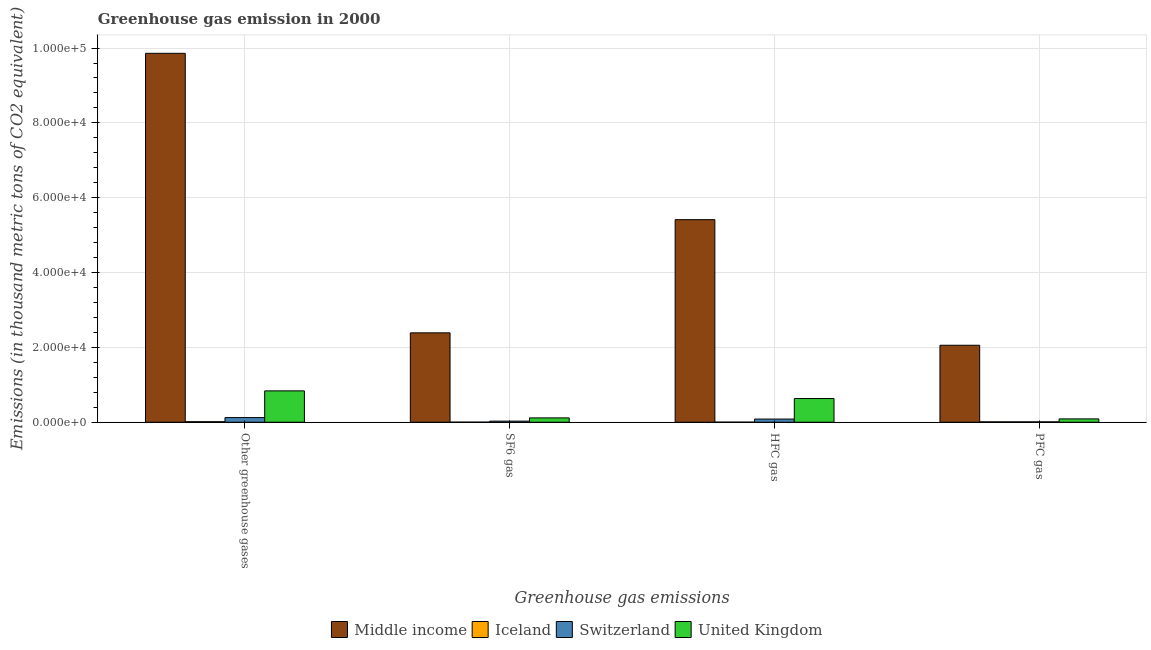How many different coloured bars are there?
Your answer should be very brief. 4. How many bars are there on the 4th tick from the left?
Your answer should be very brief. 4. What is the label of the 3rd group of bars from the left?
Provide a short and direct response. HFC gas. What is the emission of hfc gas in Middle income?
Provide a short and direct response. 5.41e+04. Across all countries, what is the maximum emission of pfc gas?
Your answer should be compact. 2.06e+04. Across all countries, what is the minimum emission of pfc gas?
Offer a very short reply. 97.9. In which country was the emission of hfc gas maximum?
Make the answer very short. Middle income. In which country was the emission of greenhouse gases minimum?
Provide a short and direct response. Iceland. What is the total emission of pfc gas in the graph?
Provide a succinct answer. 2.17e+04. What is the difference between the emission of pfc gas in Middle income and that in Iceland?
Your response must be concise. 2.05e+04. What is the difference between the emission of greenhouse gases in Middle income and the emission of sf6 gas in Switzerland?
Offer a very short reply. 9.83e+04. What is the average emission of sf6 gas per country?
Offer a very short reply. 6337.95. What is the difference between the emission of hfc gas and emission of greenhouse gases in Iceland?
Your answer should be compact. -122.5. What is the ratio of the emission of pfc gas in Middle income to that in Switzerland?
Give a very brief answer. 210.12. Is the difference between the emission of greenhouse gases in United Kingdom and Middle income greater than the difference between the emission of pfc gas in United Kingdom and Middle income?
Make the answer very short. No. What is the difference between the highest and the second highest emission of hfc gas?
Give a very brief answer. 4.78e+04. What is the difference between the highest and the lowest emission of sf6 gas?
Keep it short and to the point. 2.39e+04. Is it the case that in every country, the sum of the emission of pfc gas and emission of hfc gas is greater than the sum of emission of sf6 gas and emission of greenhouse gases?
Make the answer very short. No. What does the 3rd bar from the left in Other greenhouse gases represents?
Your response must be concise. Switzerland. What does the 1st bar from the right in HFC gas represents?
Make the answer very short. United Kingdom. Are all the bars in the graph horizontal?
Keep it short and to the point. No. How many countries are there in the graph?
Provide a short and direct response. 4. What is the difference between two consecutive major ticks on the Y-axis?
Keep it short and to the point. 2.00e+04. Does the graph contain any zero values?
Your response must be concise. No. Does the graph contain grids?
Provide a short and direct response. Yes. What is the title of the graph?
Offer a terse response. Greenhouse gas emission in 2000. Does "Korea (Democratic)" appear as one of the legend labels in the graph?
Your response must be concise. No. What is the label or title of the X-axis?
Give a very brief answer. Greenhouse gas emissions. What is the label or title of the Y-axis?
Your response must be concise. Emissions (in thousand metric tons of CO2 equivalent). What is the Emissions (in thousand metric tons of CO2 equivalent) of Middle income in Other greenhouse gases?
Your answer should be compact. 9.86e+04. What is the Emissions (in thousand metric tons of CO2 equivalent) of Iceland in Other greenhouse gases?
Give a very brief answer. 144.8. What is the Emissions (in thousand metric tons of CO2 equivalent) in Switzerland in Other greenhouse gases?
Provide a succinct answer. 1239.2. What is the Emissions (in thousand metric tons of CO2 equivalent) of United Kingdom in Other greenhouse gases?
Keep it short and to the point. 8376.7. What is the Emissions (in thousand metric tons of CO2 equivalent) in Middle income in SF6 gas?
Ensure brevity in your answer.  2.39e+04. What is the Emissions (in thousand metric tons of CO2 equivalent) of Iceland in SF6 gas?
Offer a terse response. 17.9. What is the Emissions (in thousand metric tons of CO2 equivalent) of Switzerland in SF6 gas?
Your answer should be very brief. 293.1. What is the Emissions (in thousand metric tons of CO2 equivalent) in United Kingdom in SF6 gas?
Your answer should be compact. 1154.1. What is the Emissions (in thousand metric tons of CO2 equivalent) of Middle income in HFC gas?
Offer a terse response. 5.41e+04. What is the Emissions (in thousand metric tons of CO2 equivalent) of Iceland in HFC gas?
Your answer should be compact. 22.3. What is the Emissions (in thousand metric tons of CO2 equivalent) in Switzerland in HFC gas?
Offer a terse response. 848.2. What is the Emissions (in thousand metric tons of CO2 equivalent) of United Kingdom in HFC gas?
Ensure brevity in your answer.  6332.5. What is the Emissions (in thousand metric tons of CO2 equivalent) in Middle income in PFC gas?
Provide a short and direct response. 2.06e+04. What is the Emissions (in thousand metric tons of CO2 equivalent) of Iceland in PFC gas?
Make the answer very short. 104.6. What is the Emissions (in thousand metric tons of CO2 equivalent) in Switzerland in PFC gas?
Your response must be concise. 97.9. What is the Emissions (in thousand metric tons of CO2 equivalent) in United Kingdom in PFC gas?
Your answer should be very brief. 890.1. Across all Greenhouse gas emissions, what is the maximum Emissions (in thousand metric tons of CO2 equivalent) of Middle income?
Ensure brevity in your answer.  9.86e+04. Across all Greenhouse gas emissions, what is the maximum Emissions (in thousand metric tons of CO2 equivalent) of Iceland?
Your answer should be compact. 144.8. Across all Greenhouse gas emissions, what is the maximum Emissions (in thousand metric tons of CO2 equivalent) of Switzerland?
Your answer should be compact. 1239.2. Across all Greenhouse gas emissions, what is the maximum Emissions (in thousand metric tons of CO2 equivalent) of United Kingdom?
Give a very brief answer. 8376.7. Across all Greenhouse gas emissions, what is the minimum Emissions (in thousand metric tons of CO2 equivalent) in Middle income?
Offer a terse response. 2.06e+04. Across all Greenhouse gas emissions, what is the minimum Emissions (in thousand metric tons of CO2 equivalent) of Switzerland?
Give a very brief answer. 97.9. Across all Greenhouse gas emissions, what is the minimum Emissions (in thousand metric tons of CO2 equivalent) in United Kingdom?
Give a very brief answer. 890.1. What is the total Emissions (in thousand metric tons of CO2 equivalent) of Middle income in the graph?
Your answer should be very brief. 1.97e+05. What is the total Emissions (in thousand metric tons of CO2 equivalent) in Iceland in the graph?
Your response must be concise. 289.6. What is the total Emissions (in thousand metric tons of CO2 equivalent) of Switzerland in the graph?
Make the answer very short. 2478.4. What is the total Emissions (in thousand metric tons of CO2 equivalent) of United Kingdom in the graph?
Keep it short and to the point. 1.68e+04. What is the difference between the Emissions (in thousand metric tons of CO2 equivalent) of Middle income in Other greenhouse gases and that in SF6 gas?
Keep it short and to the point. 7.47e+04. What is the difference between the Emissions (in thousand metric tons of CO2 equivalent) in Iceland in Other greenhouse gases and that in SF6 gas?
Offer a very short reply. 126.9. What is the difference between the Emissions (in thousand metric tons of CO2 equivalent) of Switzerland in Other greenhouse gases and that in SF6 gas?
Ensure brevity in your answer.  946.1. What is the difference between the Emissions (in thousand metric tons of CO2 equivalent) in United Kingdom in Other greenhouse gases and that in SF6 gas?
Your answer should be very brief. 7222.6. What is the difference between the Emissions (in thousand metric tons of CO2 equivalent) of Middle income in Other greenhouse gases and that in HFC gas?
Keep it short and to the point. 4.45e+04. What is the difference between the Emissions (in thousand metric tons of CO2 equivalent) of Iceland in Other greenhouse gases and that in HFC gas?
Ensure brevity in your answer.  122.5. What is the difference between the Emissions (in thousand metric tons of CO2 equivalent) in Switzerland in Other greenhouse gases and that in HFC gas?
Give a very brief answer. 391. What is the difference between the Emissions (in thousand metric tons of CO2 equivalent) in United Kingdom in Other greenhouse gases and that in HFC gas?
Keep it short and to the point. 2044.2. What is the difference between the Emissions (in thousand metric tons of CO2 equivalent) of Middle income in Other greenhouse gases and that in PFC gas?
Make the answer very short. 7.80e+04. What is the difference between the Emissions (in thousand metric tons of CO2 equivalent) of Iceland in Other greenhouse gases and that in PFC gas?
Keep it short and to the point. 40.2. What is the difference between the Emissions (in thousand metric tons of CO2 equivalent) of Switzerland in Other greenhouse gases and that in PFC gas?
Offer a very short reply. 1141.3. What is the difference between the Emissions (in thousand metric tons of CO2 equivalent) in United Kingdom in Other greenhouse gases and that in PFC gas?
Your answer should be compact. 7486.6. What is the difference between the Emissions (in thousand metric tons of CO2 equivalent) of Middle income in SF6 gas and that in HFC gas?
Keep it short and to the point. -3.03e+04. What is the difference between the Emissions (in thousand metric tons of CO2 equivalent) in Switzerland in SF6 gas and that in HFC gas?
Your answer should be compact. -555.1. What is the difference between the Emissions (in thousand metric tons of CO2 equivalent) in United Kingdom in SF6 gas and that in HFC gas?
Ensure brevity in your answer.  -5178.4. What is the difference between the Emissions (in thousand metric tons of CO2 equivalent) of Middle income in SF6 gas and that in PFC gas?
Provide a short and direct response. 3316.3. What is the difference between the Emissions (in thousand metric tons of CO2 equivalent) in Iceland in SF6 gas and that in PFC gas?
Give a very brief answer. -86.7. What is the difference between the Emissions (in thousand metric tons of CO2 equivalent) in Switzerland in SF6 gas and that in PFC gas?
Offer a very short reply. 195.2. What is the difference between the Emissions (in thousand metric tons of CO2 equivalent) of United Kingdom in SF6 gas and that in PFC gas?
Keep it short and to the point. 264. What is the difference between the Emissions (in thousand metric tons of CO2 equivalent) of Middle income in HFC gas and that in PFC gas?
Your answer should be very brief. 3.36e+04. What is the difference between the Emissions (in thousand metric tons of CO2 equivalent) in Iceland in HFC gas and that in PFC gas?
Provide a short and direct response. -82.3. What is the difference between the Emissions (in thousand metric tons of CO2 equivalent) of Switzerland in HFC gas and that in PFC gas?
Ensure brevity in your answer.  750.3. What is the difference between the Emissions (in thousand metric tons of CO2 equivalent) of United Kingdom in HFC gas and that in PFC gas?
Provide a short and direct response. 5442.4. What is the difference between the Emissions (in thousand metric tons of CO2 equivalent) in Middle income in Other greenhouse gases and the Emissions (in thousand metric tons of CO2 equivalent) in Iceland in SF6 gas?
Your answer should be compact. 9.86e+04. What is the difference between the Emissions (in thousand metric tons of CO2 equivalent) in Middle income in Other greenhouse gases and the Emissions (in thousand metric tons of CO2 equivalent) in Switzerland in SF6 gas?
Offer a very short reply. 9.83e+04. What is the difference between the Emissions (in thousand metric tons of CO2 equivalent) in Middle income in Other greenhouse gases and the Emissions (in thousand metric tons of CO2 equivalent) in United Kingdom in SF6 gas?
Give a very brief answer. 9.74e+04. What is the difference between the Emissions (in thousand metric tons of CO2 equivalent) of Iceland in Other greenhouse gases and the Emissions (in thousand metric tons of CO2 equivalent) of Switzerland in SF6 gas?
Your response must be concise. -148.3. What is the difference between the Emissions (in thousand metric tons of CO2 equivalent) of Iceland in Other greenhouse gases and the Emissions (in thousand metric tons of CO2 equivalent) of United Kingdom in SF6 gas?
Ensure brevity in your answer.  -1009.3. What is the difference between the Emissions (in thousand metric tons of CO2 equivalent) of Switzerland in Other greenhouse gases and the Emissions (in thousand metric tons of CO2 equivalent) of United Kingdom in SF6 gas?
Ensure brevity in your answer.  85.1. What is the difference between the Emissions (in thousand metric tons of CO2 equivalent) in Middle income in Other greenhouse gases and the Emissions (in thousand metric tons of CO2 equivalent) in Iceland in HFC gas?
Offer a very short reply. 9.86e+04. What is the difference between the Emissions (in thousand metric tons of CO2 equivalent) of Middle income in Other greenhouse gases and the Emissions (in thousand metric tons of CO2 equivalent) of Switzerland in HFC gas?
Make the answer very short. 9.77e+04. What is the difference between the Emissions (in thousand metric tons of CO2 equivalent) in Middle income in Other greenhouse gases and the Emissions (in thousand metric tons of CO2 equivalent) in United Kingdom in HFC gas?
Make the answer very short. 9.23e+04. What is the difference between the Emissions (in thousand metric tons of CO2 equivalent) in Iceland in Other greenhouse gases and the Emissions (in thousand metric tons of CO2 equivalent) in Switzerland in HFC gas?
Keep it short and to the point. -703.4. What is the difference between the Emissions (in thousand metric tons of CO2 equivalent) of Iceland in Other greenhouse gases and the Emissions (in thousand metric tons of CO2 equivalent) of United Kingdom in HFC gas?
Keep it short and to the point. -6187.7. What is the difference between the Emissions (in thousand metric tons of CO2 equivalent) in Switzerland in Other greenhouse gases and the Emissions (in thousand metric tons of CO2 equivalent) in United Kingdom in HFC gas?
Ensure brevity in your answer.  -5093.3. What is the difference between the Emissions (in thousand metric tons of CO2 equivalent) in Middle income in Other greenhouse gases and the Emissions (in thousand metric tons of CO2 equivalent) in Iceland in PFC gas?
Your response must be concise. 9.85e+04. What is the difference between the Emissions (in thousand metric tons of CO2 equivalent) of Middle income in Other greenhouse gases and the Emissions (in thousand metric tons of CO2 equivalent) of Switzerland in PFC gas?
Your answer should be very brief. 9.85e+04. What is the difference between the Emissions (in thousand metric tons of CO2 equivalent) of Middle income in Other greenhouse gases and the Emissions (in thousand metric tons of CO2 equivalent) of United Kingdom in PFC gas?
Ensure brevity in your answer.  9.77e+04. What is the difference between the Emissions (in thousand metric tons of CO2 equivalent) in Iceland in Other greenhouse gases and the Emissions (in thousand metric tons of CO2 equivalent) in Switzerland in PFC gas?
Make the answer very short. 46.9. What is the difference between the Emissions (in thousand metric tons of CO2 equivalent) in Iceland in Other greenhouse gases and the Emissions (in thousand metric tons of CO2 equivalent) in United Kingdom in PFC gas?
Your response must be concise. -745.3. What is the difference between the Emissions (in thousand metric tons of CO2 equivalent) in Switzerland in Other greenhouse gases and the Emissions (in thousand metric tons of CO2 equivalent) in United Kingdom in PFC gas?
Provide a succinct answer. 349.1. What is the difference between the Emissions (in thousand metric tons of CO2 equivalent) of Middle income in SF6 gas and the Emissions (in thousand metric tons of CO2 equivalent) of Iceland in HFC gas?
Your response must be concise. 2.39e+04. What is the difference between the Emissions (in thousand metric tons of CO2 equivalent) of Middle income in SF6 gas and the Emissions (in thousand metric tons of CO2 equivalent) of Switzerland in HFC gas?
Ensure brevity in your answer.  2.30e+04. What is the difference between the Emissions (in thousand metric tons of CO2 equivalent) of Middle income in SF6 gas and the Emissions (in thousand metric tons of CO2 equivalent) of United Kingdom in HFC gas?
Give a very brief answer. 1.76e+04. What is the difference between the Emissions (in thousand metric tons of CO2 equivalent) of Iceland in SF6 gas and the Emissions (in thousand metric tons of CO2 equivalent) of Switzerland in HFC gas?
Your response must be concise. -830.3. What is the difference between the Emissions (in thousand metric tons of CO2 equivalent) of Iceland in SF6 gas and the Emissions (in thousand metric tons of CO2 equivalent) of United Kingdom in HFC gas?
Offer a very short reply. -6314.6. What is the difference between the Emissions (in thousand metric tons of CO2 equivalent) of Switzerland in SF6 gas and the Emissions (in thousand metric tons of CO2 equivalent) of United Kingdom in HFC gas?
Offer a terse response. -6039.4. What is the difference between the Emissions (in thousand metric tons of CO2 equivalent) in Middle income in SF6 gas and the Emissions (in thousand metric tons of CO2 equivalent) in Iceland in PFC gas?
Ensure brevity in your answer.  2.38e+04. What is the difference between the Emissions (in thousand metric tons of CO2 equivalent) in Middle income in SF6 gas and the Emissions (in thousand metric tons of CO2 equivalent) in Switzerland in PFC gas?
Provide a short and direct response. 2.38e+04. What is the difference between the Emissions (in thousand metric tons of CO2 equivalent) of Middle income in SF6 gas and the Emissions (in thousand metric tons of CO2 equivalent) of United Kingdom in PFC gas?
Offer a very short reply. 2.30e+04. What is the difference between the Emissions (in thousand metric tons of CO2 equivalent) in Iceland in SF6 gas and the Emissions (in thousand metric tons of CO2 equivalent) in Switzerland in PFC gas?
Your answer should be compact. -80. What is the difference between the Emissions (in thousand metric tons of CO2 equivalent) in Iceland in SF6 gas and the Emissions (in thousand metric tons of CO2 equivalent) in United Kingdom in PFC gas?
Offer a very short reply. -872.2. What is the difference between the Emissions (in thousand metric tons of CO2 equivalent) of Switzerland in SF6 gas and the Emissions (in thousand metric tons of CO2 equivalent) of United Kingdom in PFC gas?
Your answer should be compact. -597. What is the difference between the Emissions (in thousand metric tons of CO2 equivalent) in Middle income in HFC gas and the Emissions (in thousand metric tons of CO2 equivalent) in Iceland in PFC gas?
Keep it short and to the point. 5.40e+04. What is the difference between the Emissions (in thousand metric tons of CO2 equivalent) of Middle income in HFC gas and the Emissions (in thousand metric tons of CO2 equivalent) of Switzerland in PFC gas?
Offer a very short reply. 5.40e+04. What is the difference between the Emissions (in thousand metric tons of CO2 equivalent) in Middle income in HFC gas and the Emissions (in thousand metric tons of CO2 equivalent) in United Kingdom in PFC gas?
Offer a very short reply. 5.32e+04. What is the difference between the Emissions (in thousand metric tons of CO2 equivalent) in Iceland in HFC gas and the Emissions (in thousand metric tons of CO2 equivalent) in Switzerland in PFC gas?
Provide a succinct answer. -75.6. What is the difference between the Emissions (in thousand metric tons of CO2 equivalent) of Iceland in HFC gas and the Emissions (in thousand metric tons of CO2 equivalent) of United Kingdom in PFC gas?
Make the answer very short. -867.8. What is the difference between the Emissions (in thousand metric tons of CO2 equivalent) of Switzerland in HFC gas and the Emissions (in thousand metric tons of CO2 equivalent) of United Kingdom in PFC gas?
Make the answer very short. -41.9. What is the average Emissions (in thousand metric tons of CO2 equivalent) in Middle income per Greenhouse gas emissions?
Offer a very short reply. 4.93e+04. What is the average Emissions (in thousand metric tons of CO2 equivalent) in Iceland per Greenhouse gas emissions?
Make the answer very short. 72.4. What is the average Emissions (in thousand metric tons of CO2 equivalent) of Switzerland per Greenhouse gas emissions?
Ensure brevity in your answer.  619.6. What is the average Emissions (in thousand metric tons of CO2 equivalent) of United Kingdom per Greenhouse gas emissions?
Provide a succinct answer. 4188.35. What is the difference between the Emissions (in thousand metric tons of CO2 equivalent) of Middle income and Emissions (in thousand metric tons of CO2 equivalent) of Iceland in Other greenhouse gases?
Make the answer very short. 9.85e+04. What is the difference between the Emissions (in thousand metric tons of CO2 equivalent) in Middle income and Emissions (in thousand metric tons of CO2 equivalent) in Switzerland in Other greenhouse gases?
Make the answer very short. 9.74e+04. What is the difference between the Emissions (in thousand metric tons of CO2 equivalent) in Middle income and Emissions (in thousand metric tons of CO2 equivalent) in United Kingdom in Other greenhouse gases?
Give a very brief answer. 9.02e+04. What is the difference between the Emissions (in thousand metric tons of CO2 equivalent) of Iceland and Emissions (in thousand metric tons of CO2 equivalent) of Switzerland in Other greenhouse gases?
Provide a succinct answer. -1094.4. What is the difference between the Emissions (in thousand metric tons of CO2 equivalent) of Iceland and Emissions (in thousand metric tons of CO2 equivalent) of United Kingdom in Other greenhouse gases?
Offer a very short reply. -8231.9. What is the difference between the Emissions (in thousand metric tons of CO2 equivalent) in Switzerland and Emissions (in thousand metric tons of CO2 equivalent) in United Kingdom in Other greenhouse gases?
Make the answer very short. -7137.5. What is the difference between the Emissions (in thousand metric tons of CO2 equivalent) of Middle income and Emissions (in thousand metric tons of CO2 equivalent) of Iceland in SF6 gas?
Make the answer very short. 2.39e+04. What is the difference between the Emissions (in thousand metric tons of CO2 equivalent) in Middle income and Emissions (in thousand metric tons of CO2 equivalent) in Switzerland in SF6 gas?
Ensure brevity in your answer.  2.36e+04. What is the difference between the Emissions (in thousand metric tons of CO2 equivalent) of Middle income and Emissions (in thousand metric tons of CO2 equivalent) of United Kingdom in SF6 gas?
Your answer should be compact. 2.27e+04. What is the difference between the Emissions (in thousand metric tons of CO2 equivalent) of Iceland and Emissions (in thousand metric tons of CO2 equivalent) of Switzerland in SF6 gas?
Keep it short and to the point. -275.2. What is the difference between the Emissions (in thousand metric tons of CO2 equivalent) in Iceland and Emissions (in thousand metric tons of CO2 equivalent) in United Kingdom in SF6 gas?
Offer a terse response. -1136.2. What is the difference between the Emissions (in thousand metric tons of CO2 equivalent) in Switzerland and Emissions (in thousand metric tons of CO2 equivalent) in United Kingdom in SF6 gas?
Make the answer very short. -861. What is the difference between the Emissions (in thousand metric tons of CO2 equivalent) in Middle income and Emissions (in thousand metric tons of CO2 equivalent) in Iceland in HFC gas?
Keep it short and to the point. 5.41e+04. What is the difference between the Emissions (in thousand metric tons of CO2 equivalent) of Middle income and Emissions (in thousand metric tons of CO2 equivalent) of Switzerland in HFC gas?
Make the answer very short. 5.33e+04. What is the difference between the Emissions (in thousand metric tons of CO2 equivalent) in Middle income and Emissions (in thousand metric tons of CO2 equivalent) in United Kingdom in HFC gas?
Your response must be concise. 4.78e+04. What is the difference between the Emissions (in thousand metric tons of CO2 equivalent) of Iceland and Emissions (in thousand metric tons of CO2 equivalent) of Switzerland in HFC gas?
Give a very brief answer. -825.9. What is the difference between the Emissions (in thousand metric tons of CO2 equivalent) in Iceland and Emissions (in thousand metric tons of CO2 equivalent) in United Kingdom in HFC gas?
Your response must be concise. -6310.2. What is the difference between the Emissions (in thousand metric tons of CO2 equivalent) in Switzerland and Emissions (in thousand metric tons of CO2 equivalent) in United Kingdom in HFC gas?
Make the answer very short. -5484.3. What is the difference between the Emissions (in thousand metric tons of CO2 equivalent) in Middle income and Emissions (in thousand metric tons of CO2 equivalent) in Iceland in PFC gas?
Offer a very short reply. 2.05e+04. What is the difference between the Emissions (in thousand metric tons of CO2 equivalent) of Middle income and Emissions (in thousand metric tons of CO2 equivalent) of Switzerland in PFC gas?
Make the answer very short. 2.05e+04. What is the difference between the Emissions (in thousand metric tons of CO2 equivalent) of Middle income and Emissions (in thousand metric tons of CO2 equivalent) of United Kingdom in PFC gas?
Provide a short and direct response. 1.97e+04. What is the difference between the Emissions (in thousand metric tons of CO2 equivalent) in Iceland and Emissions (in thousand metric tons of CO2 equivalent) in Switzerland in PFC gas?
Your answer should be very brief. 6.7. What is the difference between the Emissions (in thousand metric tons of CO2 equivalent) of Iceland and Emissions (in thousand metric tons of CO2 equivalent) of United Kingdom in PFC gas?
Give a very brief answer. -785.5. What is the difference between the Emissions (in thousand metric tons of CO2 equivalent) in Switzerland and Emissions (in thousand metric tons of CO2 equivalent) in United Kingdom in PFC gas?
Keep it short and to the point. -792.2. What is the ratio of the Emissions (in thousand metric tons of CO2 equivalent) in Middle income in Other greenhouse gases to that in SF6 gas?
Give a very brief answer. 4.13. What is the ratio of the Emissions (in thousand metric tons of CO2 equivalent) of Iceland in Other greenhouse gases to that in SF6 gas?
Provide a short and direct response. 8.09. What is the ratio of the Emissions (in thousand metric tons of CO2 equivalent) in Switzerland in Other greenhouse gases to that in SF6 gas?
Ensure brevity in your answer.  4.23. What is the ratio of the Emissions (in thousand metric tons of CO2 equivalent) of United Kingdom in Other greenhouse gases to that in SF6 gas?
Your answer should be compact. 7.26. What is the ratio of the Emissions (in thousand metric tons of CO2 equivalent) of Middle income in Other greenhouse gases to that in HFC gas?
Provide a succinct answer. 1.82. What is the ratio of the Emissions (in thousand metric tons of CO2 equivalent) of Iceland in Other greenhouse gases to that in HFC gas?
Provide a succinct answer. 6.49. What is the ratio of the Emissions (in thousand metric tons of CO2 equivalent) of Switzerland in Other greenhouse gases to that in HFC gas?
Your answer should be compact. 1.46. What is the ratio of the Emissions (in thousand metric tons of CO2 equivalent) of United Kingdom in Other greenhouse gases to that in HFC gas?
Keep it short and to the point. 1.32. What is the ratio of the Emissions (in thousand metric tons of CO2 equivalent) of Middle income in Other greenhouse gases to that in PFC gas?
Your response must be concise. 4.79. What is the ratio of the Emissions (in thousand metric tons of CO2 equivalent) of Iceland in Other greenhouse gases to that in PFC gas?
Ensure brevity in your answer.  1.38. What is the ratio of the Emissions (in thousand metric tons of CO2 equivalent) of Switzerland in Other greenhouse gases to that in PFC gas?
Give a very brief answer. 12.66. What is the ratio of the Emissions (in thousand metric tons of CO2 equivalent) in United Kingdom in Other greenhouse gases to that in PFC gas?
Provide a succinct answer. 9.41. What is the ratio of the Emissions (in thousand metric tons of CO2 equivalent) in Middle income in SF6 gas to that in HFC gas?
Offer a very short reply. 0.44. What is the ratio of the Emissions (in thousand metric tons of CO2 equivalent) of Iceland in SF6 gas to that in HFC gas?
Your response must be concise. 0.8. What is the ratio of the Emissions (in thousand metric tons of CO2 equivalent) of Switzerland in SF6 gas to that in HFC gas?
Offer a terse response. 0.35. What is the ratio of the Emissions (in thousand metric tons of CO2 equivalent) of United Kingdom in SF6 gas to that in HFC gas?
Your answer should be compact. 0.18. What is the ratio of the Emissions (in thousand metric tons of CO2 equivalent) of Middle income in SF6 gas to that in PFC gas?
Make the answer very short. 1.16. What is the ratio of the Emissions (in thousand metric tons of CO2 equivalent) of Iceland in SF6 gas to that in PFC gas?
Your response must be concise. 0.17. What is the ratio of the Emissions (in thousand metric tons of CO2 equivalent) in Switzerland in SF6 gas to that in PFC gas?
Make the answer very short. 2.99. What is the ratio of the Emissions (in thousand metric tons of CO2 equivalent) of United Kingdom in SF6 gas to that in PFC gas?
Ensure brevity in your answer.  1.3. What is the ratio of the Emissions (in thousand metric tons of CO2 equivalent) of Middle income in HFC gas to that in PFC gas?
Your answer should be very brief. 2.63. What is the ratio of the Emissions (in thousand metric tons of CO2 equivalent) in Iceland in HFC gas to that in PFC gas?
Give a very brief answer. 0.21. What is the ratio of the Emissions (in thousand metric tons of CO2 equivalent) of Switzerland in HFC gas to that in PFC gas?
Your response must be concise. 8.66. What is the ratio of the Emissions (in thousand metric tons of CO2 equivalent) of United Kingdom in HFC gas to that in PFC gas?
Provide a succinct answer. 7.11. What is the difference between the highest and the second highest Emissions (in thousand metric tons of CO2 equivalent) in Middle income?
Give a very brief answer. 4.45e+04. What is the difference between the highest and the second highest Emissions (in thousand metric tons of CO2 equivalent) in Iceland?
Your response must be concise. 40.2. What is the difference between the highest and the second highest Emissions (in thousand metric tons of CO2 equivalent) in Switzerland?
Make the answer very short. 391. What is the difference between the highest and the second highest Emissions (in thousand metric tons of CO2 equivalent) of United Kingdom?
Provide a short and direct response. 2044.2. What is the difference between the highest and the lowest Emissions (in thousand metric tons of CO2 equivalent) of Middle income?
Offer a terse response. 7.80e+04. What is the difference between the highest and the lowest Emissions (in thousand metric tons of CO2 equivalent) of Iceland?
Your answer should be compact. 126.9. What is the difference between the highest and the lowest Emissions (in thousand metric tons of CO2 equivalent) in Switzerland?
Offer a very short reply. 1141.3. What is the difference between the highest and the lowest Emissions (in thousand metric tons of CO2 equivalent) of United Kingdom?
Keep it short and to the point. 7486.6. 